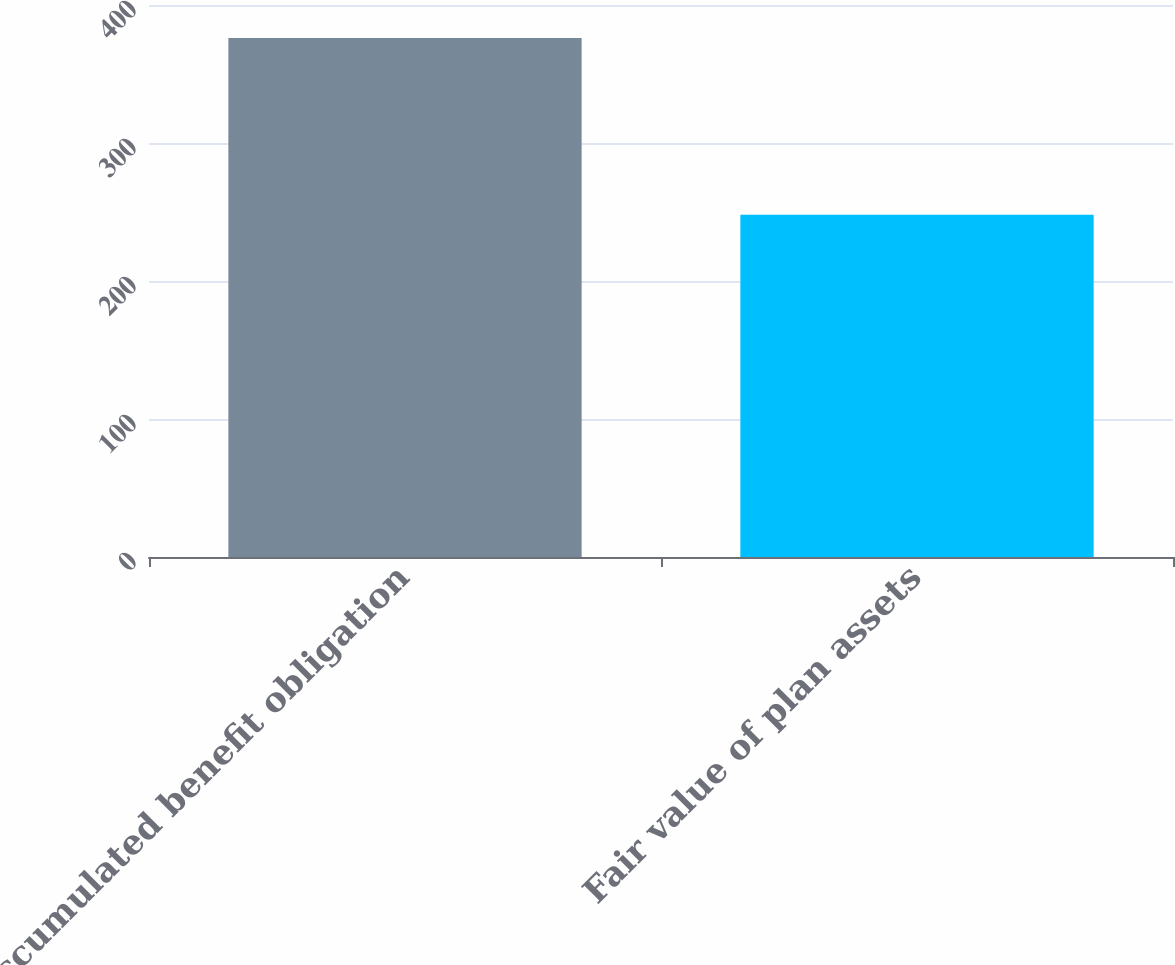Convert chart to OTSL. <chart><loc_0><loc_0><loc_500><loc_500><bar_chart><fcel>Accumulated benefit obligation<fcel>Fair value of plan assets<nl><fcel>376<fcel>248<nl></chart> 